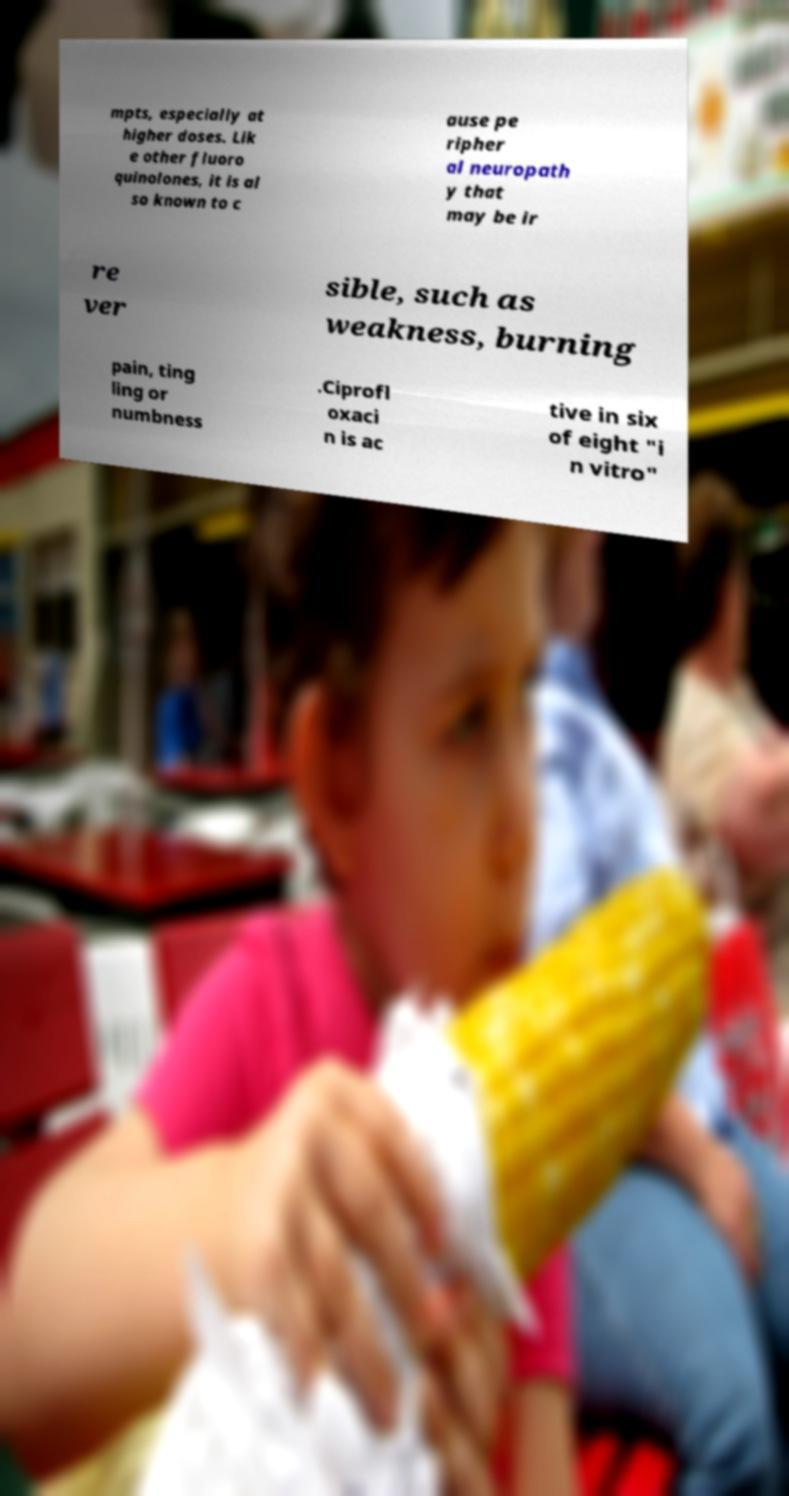Please read and relay the text visible in this image. What does it say? mpts, especially at higher doses. Lik e other fluoro quinolones, it is al so known to c ause pe ripher al neuropath y that may be ir re ver sible, such as weakness, burning pain, ting ling or numbness .Ciprofl oxaci n is ac tive in six of eight "i n vitro" 